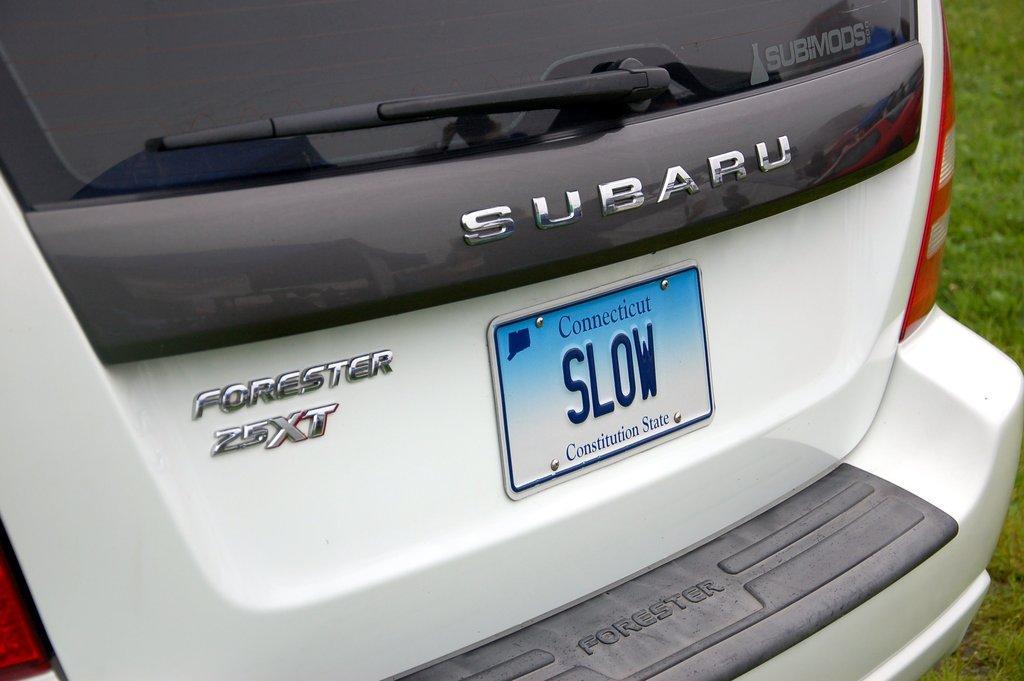In one or two sentences, can you explain what this image depicts? In this image we can see a white color vehicle with some text on it, also we can see the grass. 